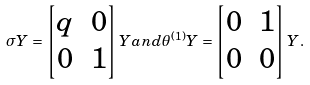Convert formula to latex. <formula><loc_0><loc_0><loc_500><loc_500>\sigma Y = \begin{bmatrix} q & 0 \\ 0 & 1 \end{bmatrix} Y a n d \theta ^ { ( 1 ) } Y = \begin{bmatrix} 0 & 1 \\ 0 & 0 \end{bmatrix} Y .</formula> 